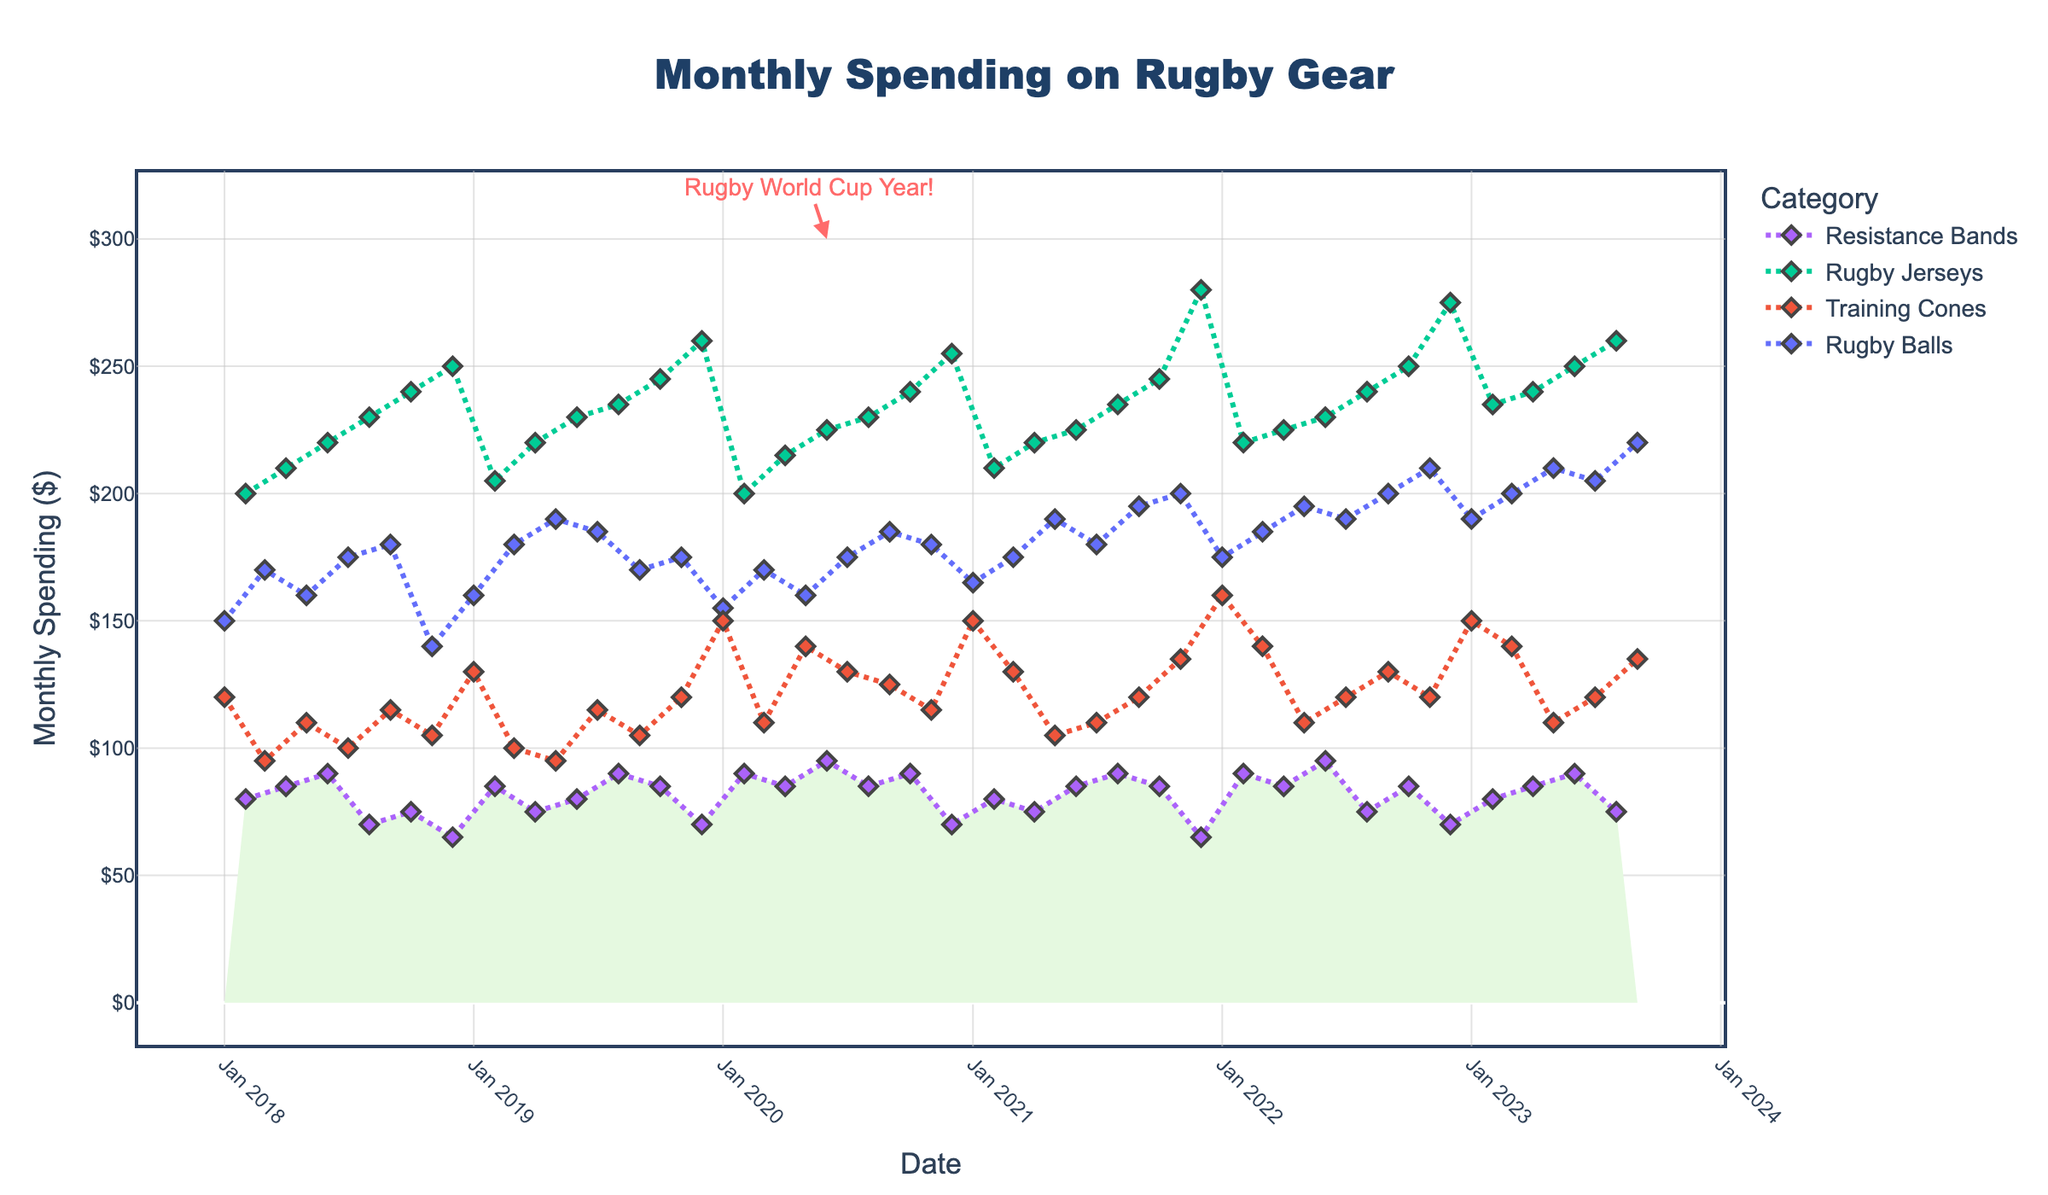What is the title of the figure? The title of the figure is prominently displayed at the top and is generally larger and often in bold text.
Answer: Monthly Spending on Rugby Gear How much was spent on Rugby Balls in July 2019? To find this, look for the July 2019 data point along the x-axis and refer to the corresponding value of Rugby Balls.
Answer: $185 What was the highest monthly spending on Rugby Jerseys over the five years? Identify the peak value in the Rugby Jerseys line. The year and value will clearly stand out in the time series plot.
Answer: $280 Which category had the lowest spending in December 2022? For December 2022, check which category has the lowest value by comparing the data points around December 2022.
Answer: Resistance Bands What is the average monthly spending on Training Cones in 2022? Add the monthly spending on Training Cones for each month in 2022: $160 (Jan) + $140 (Mar) + $110 (May) + $120 (Jul) + $130 (Sep) = $660. Then divide the total by 5 months.
Answer: $132 Which categories showed a decrease in spending from January 2023 to February 2023? Compare the spending values in January 2023 and February 2023; identify categories where the February value is lower than the January value.
Answer: Training Cones, Resistance Bands What is the total spending on Rugby Balls in 2020? Sum up the spending values on Rugby Balls for each month in 2020: $155 (Jan) + $170 (Mar) + $160 (May) + $175 (Jul) + $185 (Sep) + $180 (Nov) = $1025
Answer: $1025 When did Rugby Jerseys spending first exceed $250 in a single month? Look along the Rugby Jerseys line for the first instance where the spending crosses the $250 mark and note the corresponding date on the x-axis.
Answer: December 2019 Compare the spending trend on Rugby Jerseys and Resistance Bands in 2019. Which category increased more consistently? Evaluate the spending patterns of both categories by looking at their respective lines; Rugby Jerseys should show more frequent increases.
Answer: Rugby Jerseys 